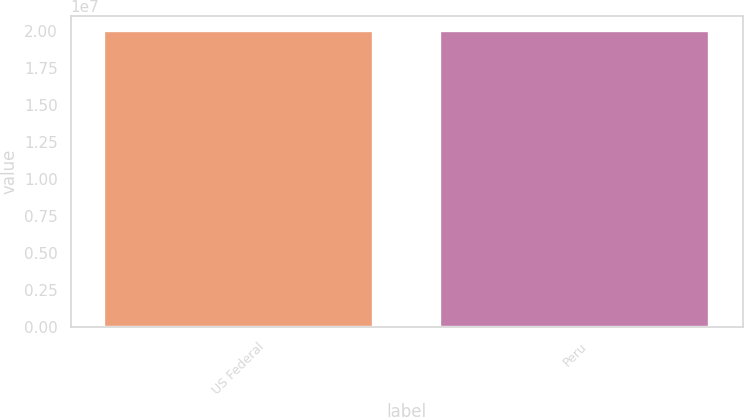Convert chart. <chart><loc_0><loc_0><loc_500><loc_500><bar_chart><fcel>US Federal<fcel>Peru<nl><fcel>2.0032e+07<fcel>2.0022e+07<nl></chart> 